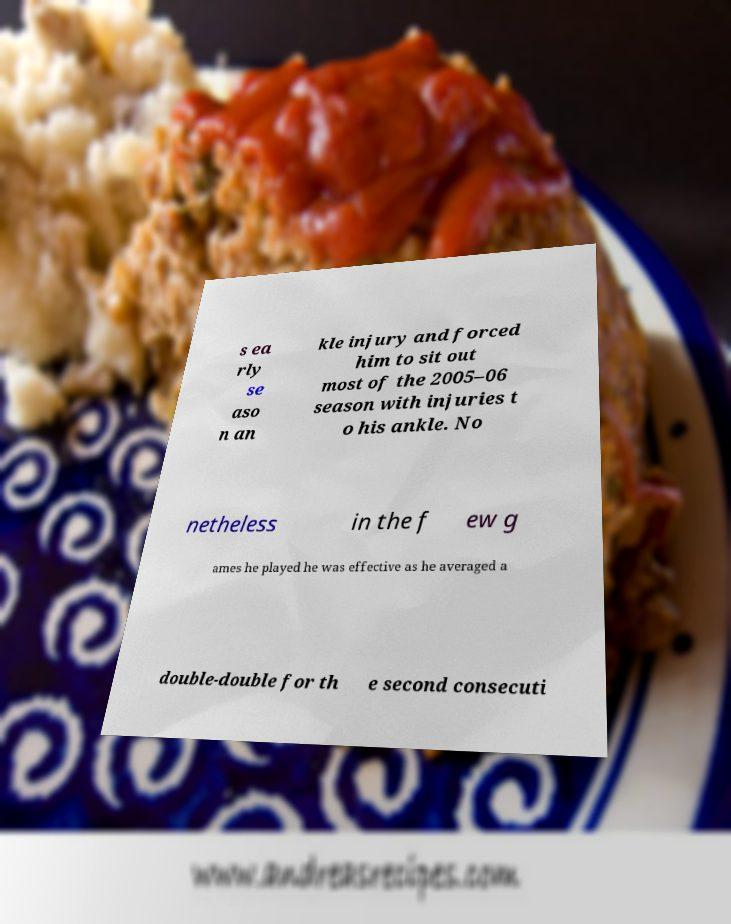For documentation purposes, I need the text within this image transcribed. Could you provide that? s ea rly se aso n an kle injury and forced him to sit out most of the 2005–06 season with injuries t o his ankle. No netheless in the f ew g ames he played he was effective as he averaged a double-double for th e second consecuti 